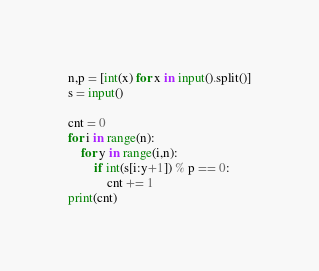Convert code to text. <code><loc_0><loc_0><loc_500><loc_500><_Python_>n,p = [int(x) for x in input().split()]
s = input()

cnt = 0
for i in range(n):
    for y in range(i,n):
        if int(s[i:y+1]) % p == 0:
            cnt += 1
print(cnt)</code> 